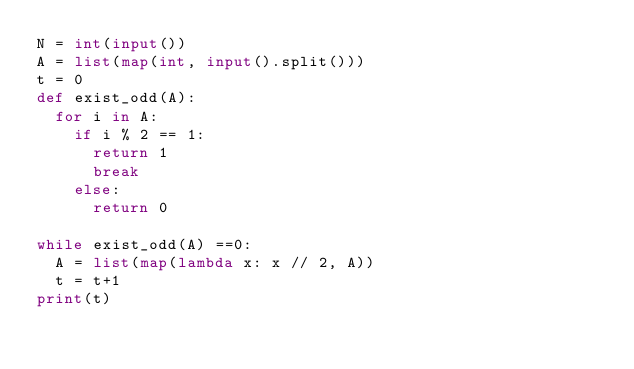<code> <loc_0><loc_0><loc_500><loc_500><_Python_>N = int(input())
A = list(map(int, input().split()))
t = 0
def exist_odd(A):
  for i in A:
    if i % 2 == 1:
      return 1
      break
    else:
   	  return 0
  
while exist_odd(A) ==0:
  A = list(map(lambda x: x // 2, A))
  t = t+1
print(t)</code> 